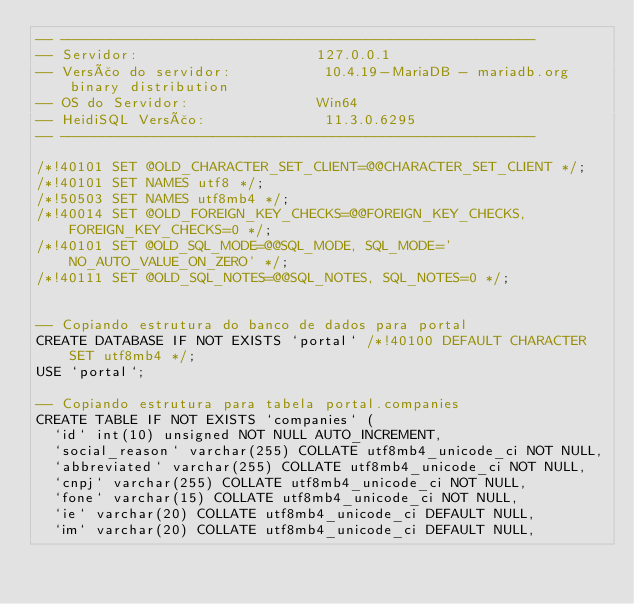Convert code to text. <code><loc_0><loc_0><loc_500><loc_500><_SQL_>-- --------------------------------------------------------
-- Servidor:                     127.0.0.1
-- Versão do servidor:           10.4.19-MariaDB - mariadb.org binary distribution
-- OS do Servidor:               Win64
-- HeidiSQL Versão:              11.3.0.6295
-- --------------------------------------------------------

/*!40101 SET @OLD_CHARACTER_SET_CLIENT=@@CHARACTER_SET_CLIENT */;
/*!40101 SET NAMES utf8 */;
/*!50503 SET NAMES utf8mb4 */;
/*!40014 SET @OLD_FOREIGN_KEY_CHECKS=@@FOREIGN_KEY_CHECKS, FOREIGN_KEY_CHECKS=0 */;
/*!40101 SET @OLD_SQL_MODE=@@SQL_MODE, SQL_MODE='NO_AUTO_VALUE_ON_ZERO' */;
/*!40111 SET @OLD_SQL_NOTES=@@SQL_NOTES, SQL_NOTES=0 */;


-- Copiando estrutura do banco de dados para portal
CREATE DATABASE IF NOT EXISTS `portal` /*!40100 DEFAULT CHARACTER SET utf8mb4 */;
USE `portal`;

-- Copiando estrutura para tabela portal.companies
CREATE TABLE IF NOT EXISTS `companies` (
  `id` int(10) unsigned NOT NULL AUTO_INCREMENT,
  `social_reason` varchar(255) COLLATE utf8mb4_unicode_ci NOT NULL,
  `abbreviated` varchar(255) COLLATE utf8mb4_unicode_ci NOT NULL,
  `cnpj` varchar(255) COLLATE utf8mb4_unicode_ci NOT NULL,
  `fone` varchar(15) COLLATE utf8mb4_unicode_ci NOT NULL,
  `ie` varchar(20) COLLATE utf8mb4_unicode_ci DEFAULT NULL,
  `im` varchar(20) COLLATE utf8mb4_unicode_ci DEFAULT NULL,</code> 